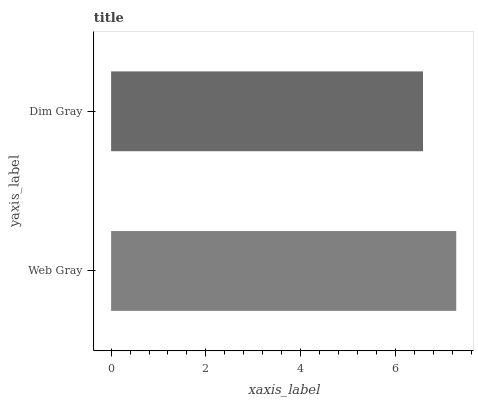Is Dim Gray the minimum?
Answer yes or no. Yes. Is Web Gray the maximum?
Answer yes or no. Yes. Is Dim Gray the maximum?
Answer yes or no. No. Is Web Gray greater than Dim Gray?
Answer yes or no. Yes. Is Dim Gray less than Web Gray?
Answer yes or no. Yes. Is Dim Gray greater than Web Gray?
Answer yes or no. No. Is Web Gray less than Dim Gray?
Answer yes or no. No. Is Web Gray the high median?
Answer yes or no. Yes. Is Dim Gray the low median?
Answer yes or no. Yes. Is Dim Gray the high median?
Answer yes or no. No. Is Web Gray the low median?
Answer yes or no. No. 